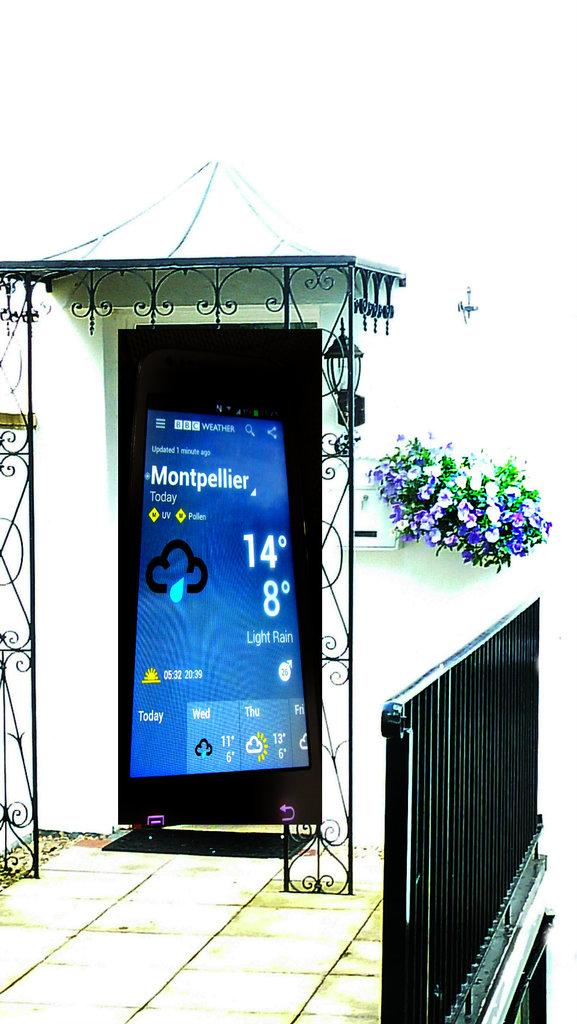<image>
Give a short and clear explanation of the subsequent image. A large phone shows the weather in Montpellier on its screen. 